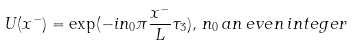Convert formula to latex. <formula><loc_0><loc_0><loc_500><loc_500>U ( x ^ { - } ) = \exp ( { - i n _ { 0 } \pi { \frac { x ^ { - } } { L } } \tau _ { 3 } ) } , \, n _ { 0 } \, { a n \, e v e n \, i n t e g e r }</formula> 